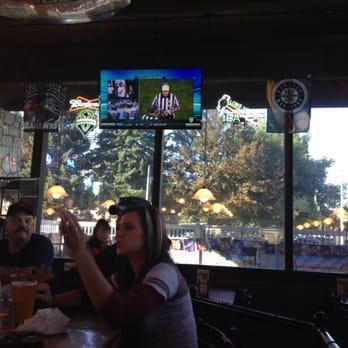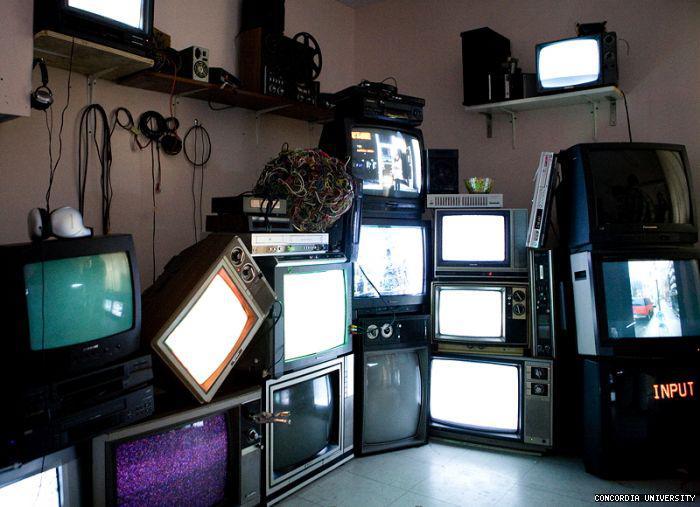The first image is the image on the left, the second image is the image on the right. For the images displayed, is the sentence "At least one person's face is visible" factually correct? Answer yes or no. Yes. The first image is the image on the left, the second image is the image on the right. Evaluate the accuracy of this statement regarding the images: "In at least one image, one or more overhead televisions are playing in a restaurant.". Is it true? Answer yes or no. Yes. 